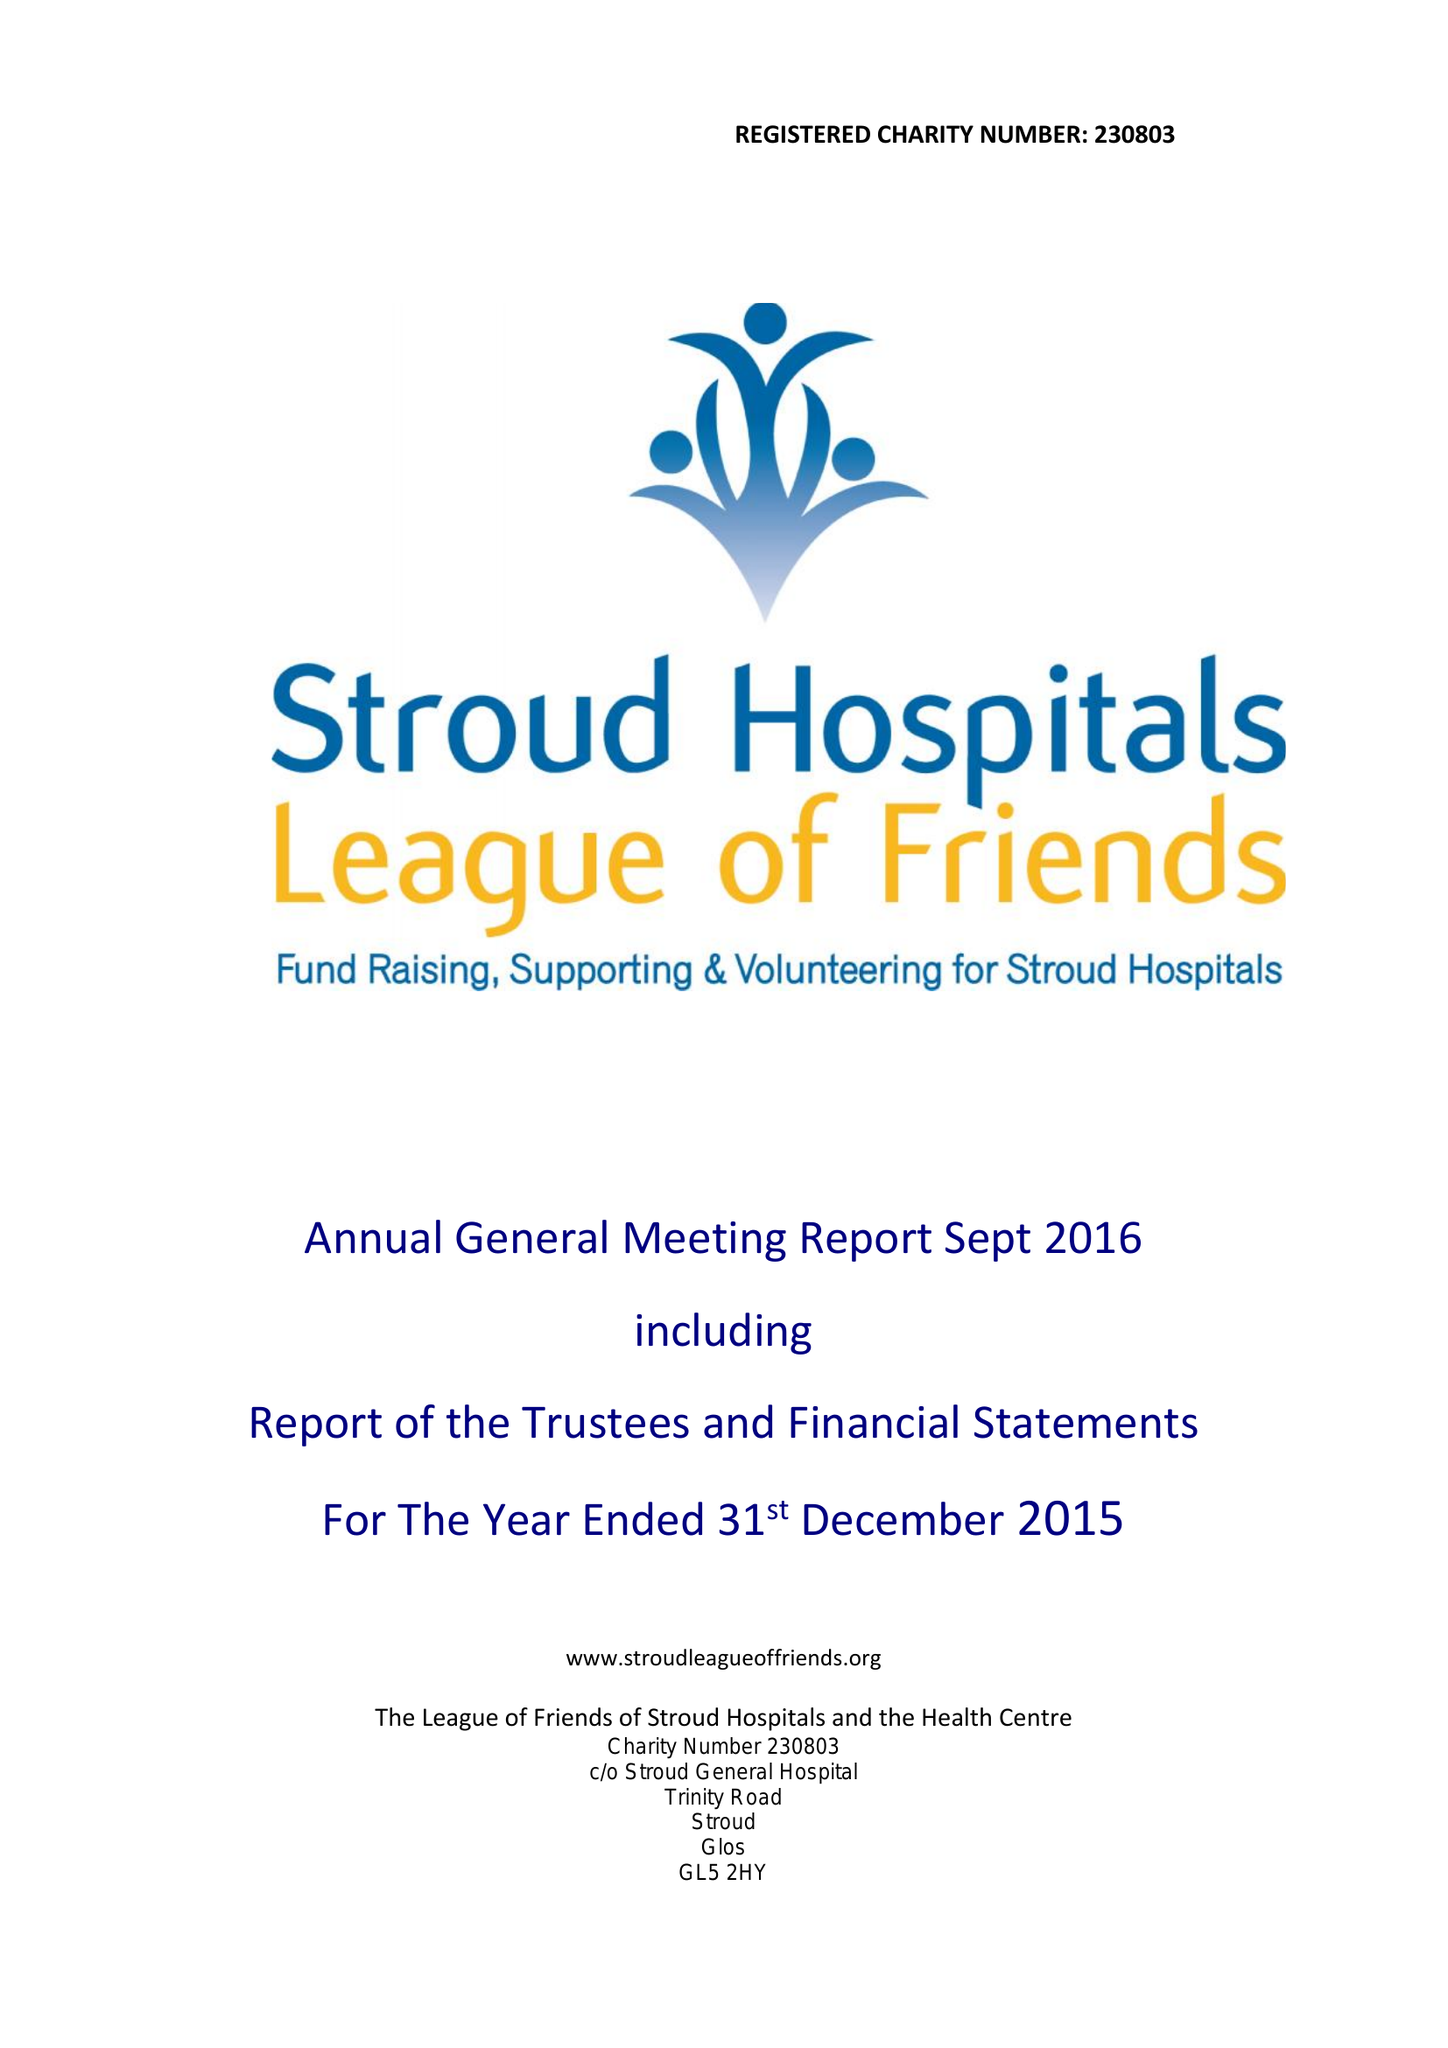What is the value for the income_annually_in_british_pounds?
Answer the question using a single word or phrase. 726025.00 